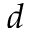<formula> <loc_0><loc_0><loc_500><loc_500>d</formula> 